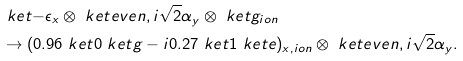Convert formula to latex. <formula><loc_0><loc_0><loc_500><loc_500>& \ k e t { - \epsilon } _ { x } \otimes \ k e t { e v e n , i \sqrt { 2 } \alpha } _ { y } \otimes \ k e t { g } _ { i o n } \\ & \rightarrow ( 0 . 9 6 \ k e t { 0 } \ k e t { g } - i 0 . 2 7 \ k e t { 1 } \ k e t { e } ) _ { x , i o n } \otimes \ k e t { e v e n , i \sqrt { 2 } \alpha } _ { y } .</formula> 